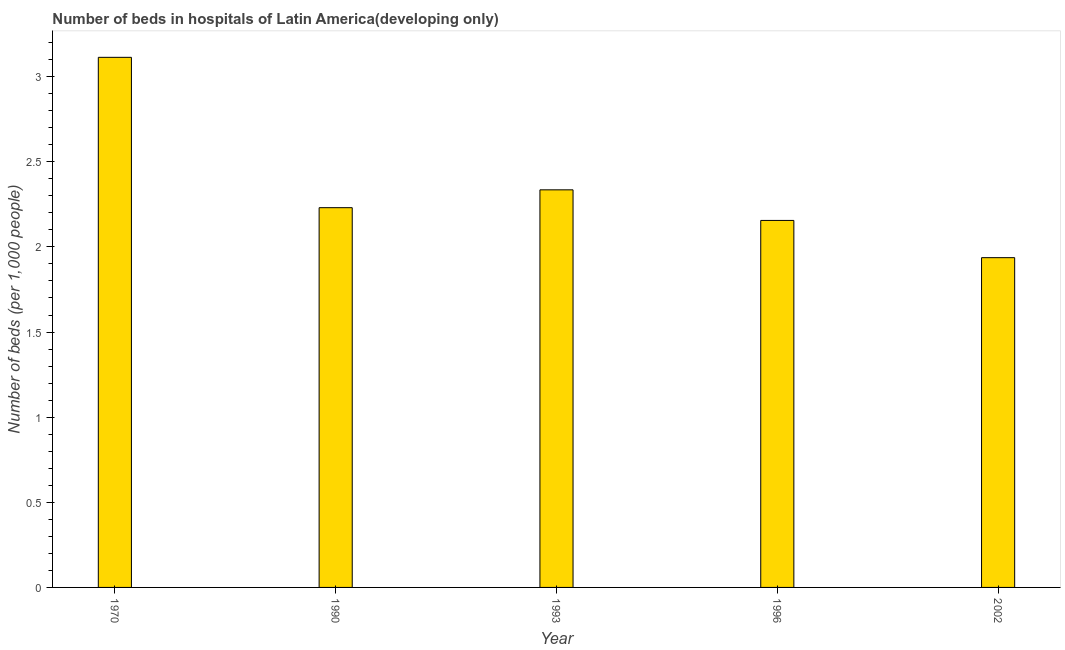Does the graph contain any zero values?
Offer a terse response. No. Does the graph contain grids?
Offer a very short reply. No. What is the title of the graph?
Your response must be concise. Number of beds in hospitals of Latin America(developing only). What is the label or title of the Y-axis?
Your answer should be compact. Number of beds (per 1,0 people). What is the number of hospital beds in 1990?
Ensure brevity in your answer.  2.23. Across all years, what is the maximum number of hospital beds?
Provide a succinct answer. 3.11. Across all years, what is the minimum number of hospital beds?
Your answer should be very brief. 1.94. In which year was the number of hospital beds maximum?
Keep it short and to the point. 1970. In which year was the number of hospital beds minimum?
Offer a very short reply. 2002. What is the sum of the number of hospital beds?
Give a very brief answer. 11.77. What is the difference between the number of hospital beds in 1970 and 1996?
Your answer should be compact. 0.96. What is the average number of hospital beds per year?
Your answer should be compact. 2.35. What is the median number of hospital beds?
Your response must be concise. 2.23. Do a majority of the years between 1990 and 1993 (inclusive) have number of hospital beds greater than 2.2 %?
Your response must be concise. Yes. What is the ratio of the number of hospital beds in 1993 to that in 2002?
Offer a very short reply. 1.21. Is the number of hospital beds in 1970 less than that in 2002?
Your answer should be compact. No. Is the difference between the number of hospital beds in 1990 and 1993 greater than the difference between any two years?
Your response must be concise. No. What is the difference between the highest and the second highest number of hospital beds?
Your response must be concise. 0.78. Is the sum of the number of hospital beds in 1996 and 2002 greater than the maximum number of hospital beds across all years?
Give a very brief answer. Yes. What is the difference between the highest and the lowest number of hospital beds?
Offer a terse response. 1.18. In how many years, is the number of hospital beds greater than the average number of hospital beds taken over all years?
Make the answer very short. 1. How many years are there in the graph?
Your response must be concise. 5. What is the difference between two consecutive major ticks on the Y-axis?
Offer a very short reply. 0.5. Are the values on the major ticks of Y-axis written in scientific E-notation?
Your answer should be very brief. No. What is the Number of beds (per 1,000 people) in 1970?
Offer a very short reply. 3.11. What is the Number of beds (per 1,000 people) in 1990?
Offer a very short reply. 2.23. What is the Number of beds (per 1,000 people) of 1993?
Your answer should be very brief. 2.34. What is the Number of beds (per 1,000 people) of 1996?
Your answer should be compact. 2.16. What is the Number of beds (per 1,000 people) in 2002?
Offer a very short reply. 1.94. What is the difference between the Number of beds (per 1,000 people) in 1970 and 1990?
Give a very brief answer. 0.88. What is the difference between the Number of beds (per 1,000 people) in 1970 and 1993?
Give a very brief answer. 0.78. What is the difference between the Number of beds (per 1,000 people) in 1970 and 1996?
Provide a short and direct response. 0.96. What is the difference between the Number of beds (per 1,000 people) in 1970 and 2002?
Offer a terse response. 1.18. What is the difference between the Number of beds (per 1,000 people) in 1990 and 1993?
Your response must be concise. -0.1. What is the difference between the Number of beds (per 1,000 people) in 1990 and 1996?
Make the answer very short. 0.07. What is the difference between the Number of beds (per 1,000 people) in 1990 and 2002?
Give a very brief answer. 0.29. What is the difference between the Number of beds (per 1,000 people) in 1993 and 1996?
Keep it short and to the point. 0.18. What is the difference between the Number of beds (per 1,000 people) in 1993 and 2002?
Give a very brief answer. 0.4. What is the difference between the Number of beds (per 1,000 people) in 1996 and 2002?
Keep it short and to the point. 0.22. What is the ratio of the Number of beds (per 1,000 people) in 1970 to that in 1990?
Your answer should be compact. 1.4. What is the ratio of the Number of beds (per 1,000 people) in 1970 to that in 1993?
Your response must be concise. 1.33. What is the ratio of the Number of beds (per 1,000 people) in 1970 to that in 1996?
Make the answer very short. 1.44. What is the ratio of the Number of beds (per 1,000 people) in 1970 to that in 2002?
Your response must be concise. 1.61. What is the ratio of the Number of beds (per 1,000 people) in 1990 to that in 1993?
Keep it short and to the point. 0.95. What is the ratio of the Number of beds (per 1,000 people) in 1990 to that in 1996?
Your answer should be compact. 1.03. What is the ratio of the Number of beds (per 1,000 people) in 1990 to that in 2002?
Offer a terse response. 1.15. What is the ratio of the Number of beds (per 1,000 people) in 1993 to that in 1996?
Provide a succinct answer. 1.08. What is the ratio of the Number of beds (per 1,000 people) in 1993 to that in 2002?
Your answer should be compact. 1.21. What is the ratio of the Number of beds (per 1,000 people) in 1996 to that in 2002?
Offer a very short reply. 1.11. 